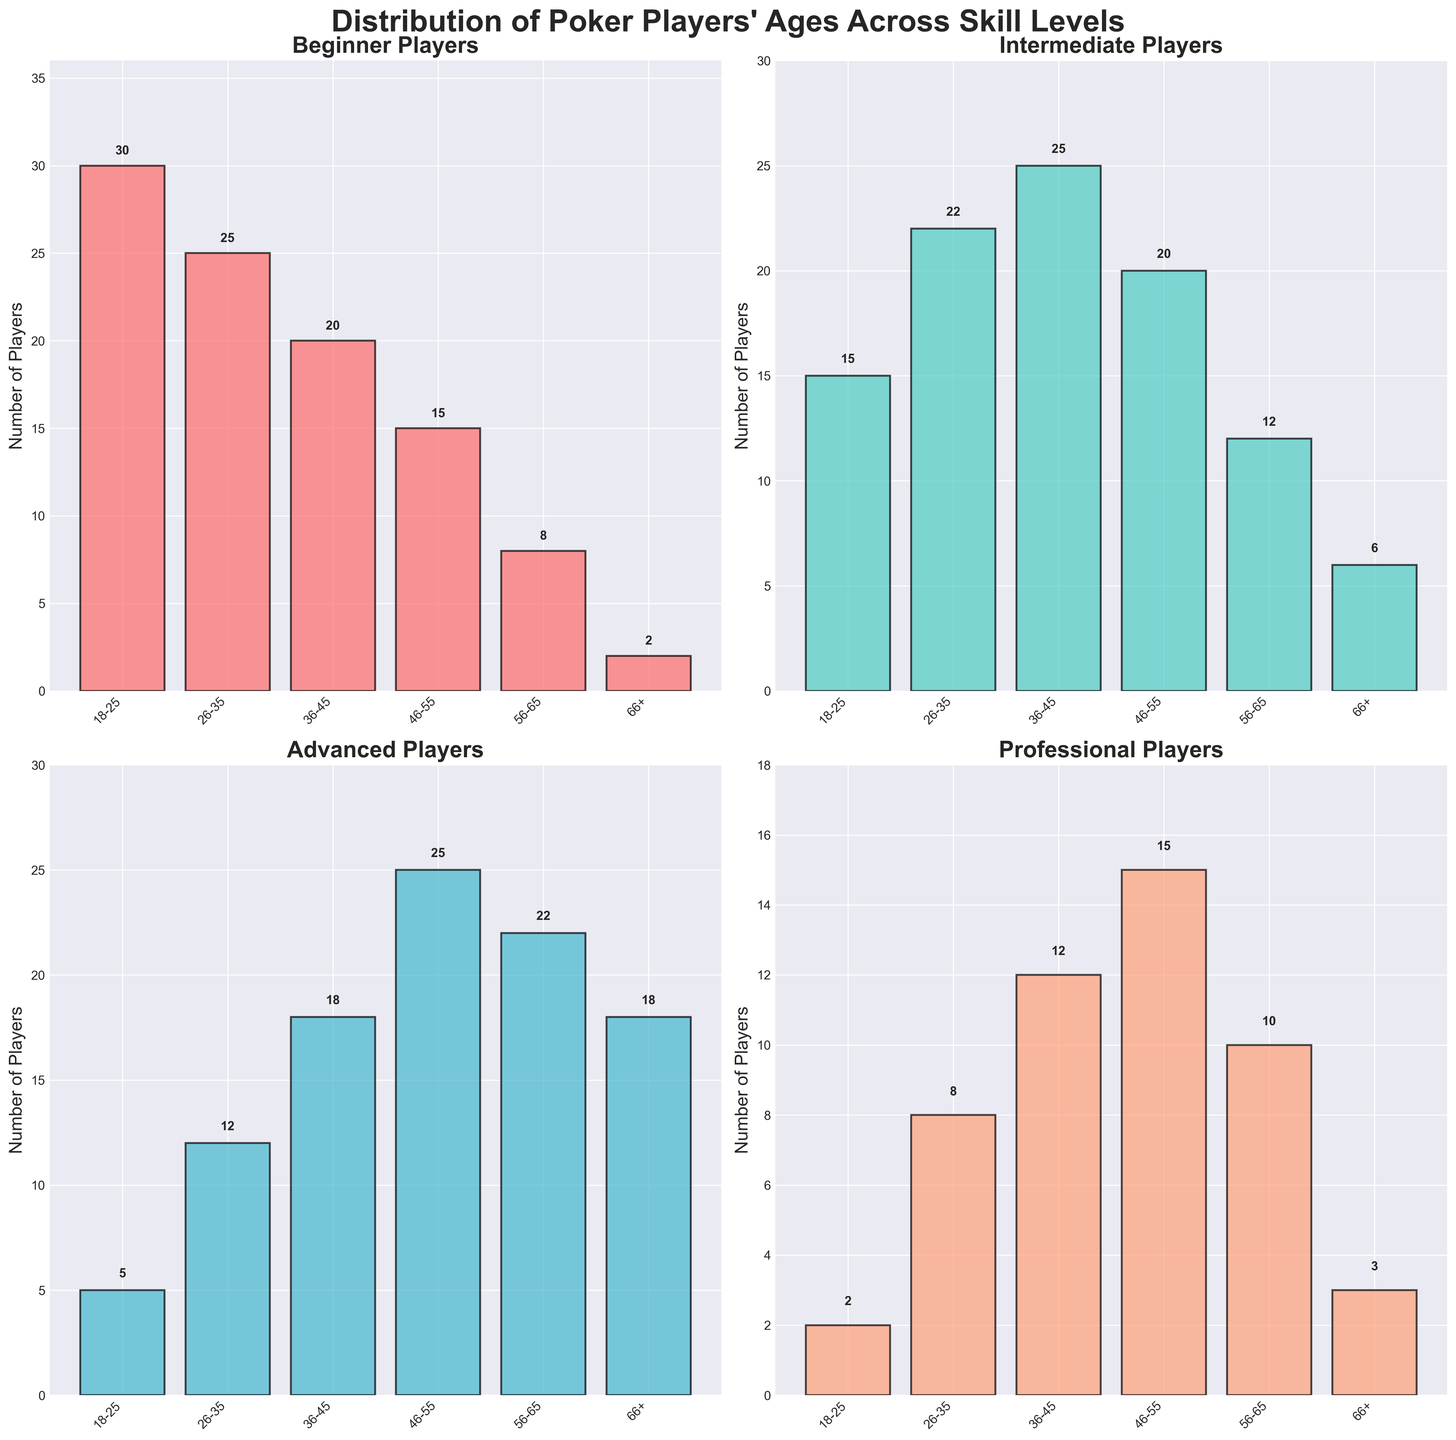Which age group has the highest number of beginner players? By looking at the Beginner subplot, the highest bar corresponds to the 18-25 age group, with a height of 30.
Answer: 18-25 Which skill level has the highest number of players aged 46-55? By comparing the heights of the bars in all subplots for the 46-55 age group, the tallest bar is in the Advanced subplot with a height of 25 players.
Answer: Advanced What's the total number of professional players aged 56 and above? Adding the numbers of professional players in the 56-65 age group and the 66+ age group: 10 + 3 = 13.
Answer: 13 Which age group has the smallest difference between intermediate and advanced players? Subtract the number of advanced players from intermediate players in each age group and compare: 
For 18-25: 15 - 5 = 10
For 26-35: 22 - 12 = 10
For 36-45: 25 - 18 = 7
For 46-55: 20 - 25 = -5 (difference is 5)
For 56-65: 12 - 22 = -10 (difference is 10)
For 66+: 6 - 18 = -12 (difference is 12)
The smallest absolute difference is 5 for the 46-55 age group.
Answer: 46-55 What is the average number of advanced players across all age groups? Adding the number of advanced players in all age groups and then dividing by the number of age groups: (5 + 12 + 18 + 25 + 22 + 18) / 6 = 100 / 6 ≈ 16.67
Answer: 16.67 Are there more beginners or professionals aged 36-45? By comparing the bars for the 36-45 age group in the Beginner and Professional subplots, beginners have 20 players and professionals have 12.
Answer: Beginners What is the total number of poker players aged 18-25 across all skill levels? Summing the number of players for each skill level in the 18-25 age group: 30 (Beginner) + 15 (Intermediate) + 5 (Advanced) + 2 (Professional) = 52.
Answer: 52 Which age group shows the highest number of players overall in the Intermediate skill level? By looking at the Intermediate subplot, the highest bar corresponds to the 36-45 age group, with a height of 25.
Answer: 36-45 How does the trend of professional players change with age? By analyzing the Professional subplot, there is a general increase in the number of professional players from the 18-25 age group to the 46-55 age group, followed by a decrease in older age groups.
Answer: Increases then decreases How many age groups have fewer than 10 Beginner players? From the Beginner subplot, the bars for the age groups 56-65 and 66+ are below 10 players each.
Answer: 2 